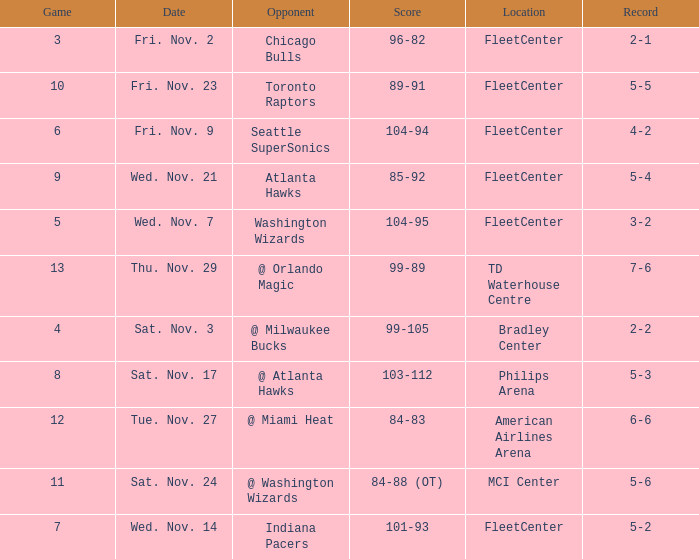What is the earliest game with a score of 99-89? 13.0. 